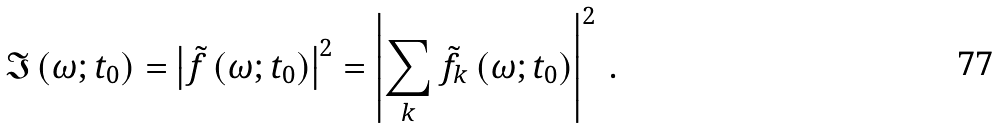<formula> <loc_0><loc_0><loc_500><loc_500>\mathfrak { I } \left ( \omega ; t _ { 0 } \right ) = \left | \tilde { f } \left ( \omega ; t _ { 0 } \right ) \right | ^ { 2 } = \left | \sum _ { k } \tilde { f } _ { k } \left ( \omega ; t _ { 0 } \right ) \right | ^ { 2 } \, .</formula> 